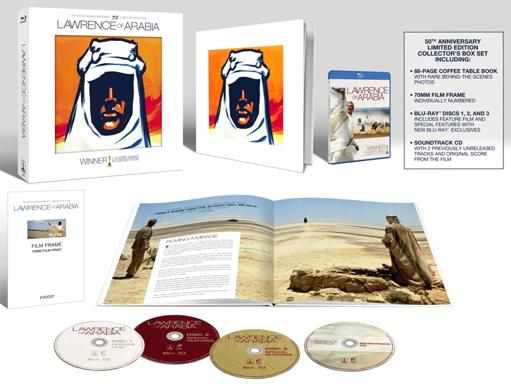What information is given about the Lawrence of Arabia film in the image? The image provides detailed information about the 'Lawrence of Arabia' 50th Anniversary Collector's Box Set. This set includes a specially designed box featuring artwork inspired by the film, four Blu-ray discs containing the movie and special features, and a coffee table book with behind-the-scenes photos and historical insights. Additionally, the set highlights a unique 'Lawrence of Arabia Film Frame' included within, making it a valuable collectible for fans and historians of cinema. 